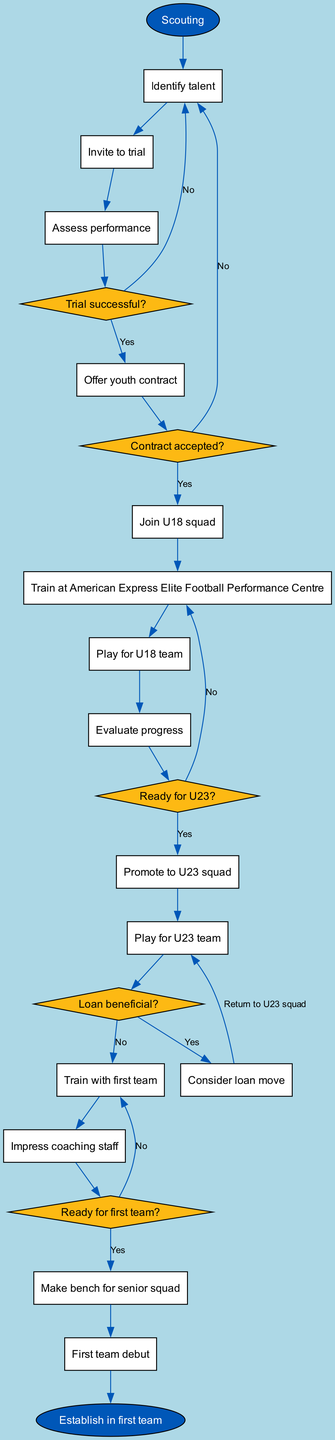What is the initial node in the diagram? The initial node is defined in the "initialNode" key of the data, which indicates the starting point of the activity diagram. According to the provided data, it is "Scouting."
Answer: Scouting How many activities are listed in the diagram? To find the number of activities, we can count the entries in the "activities" section of the data. There are 14 activities listed.
Answer: 14 What follows after "Assess performance"? Following "Assess performance," the flow of the diagram leads to a decision node "Trial successful?" which is created after this activity. The next node is "Offer youth contract."
Answer: Offer youth contract If a player is not ready for U23, where do they return? The decision "Ready for U23?" branches out from "Evaluate progress." If the answer is "No," the path leads back to "Train at American Express Elite Football Performance Centre," which means the player returns to that activity to continue their development.
Answer: Train at American Express Elite Football Performance Centre What decision follows the activity "Join U18 squad"? After "Join U18 squad," the next activity is "Train at American Express Elite Football Performance Centre," which indicates the progression from the U18 squad to preparatory training before playing matches.
Answer: Train at American Express Elite Football Performance Centre How does a player make their first team debut? The path to a player's first team debut includes several milestones: they must impress the coaching staff after training with the first team, then they must make the bench for the senior squad before finally achieving their "First team debut."
Answer: Impress coaching staff If the answer is "Yes" to the decision "Loan beneficial?", what is the next step? From the decision "Loan beneficial?", if the answer is "Yes," the next activity flows to "Consider loan move," indicating a consideration for a loan opportunity.
Answer: Consider loan move What is the final node in the diagram? The final node, as specified at the end of the flow in the diagram, represents the conclusion of the progression and is labeled "Establish in first team." This indicates the ultimate goal for players progressing through the academy.
Answer: Establish in first team What is the fate of a player who accepts a youth contract? If a player successfully receives a youth contract after the "Trial successful?" decision is "Yes," they will proceed to become part of the "U18 squad" as per the flow of actions indicated in the diagram.
Answer: Join U18 squad 